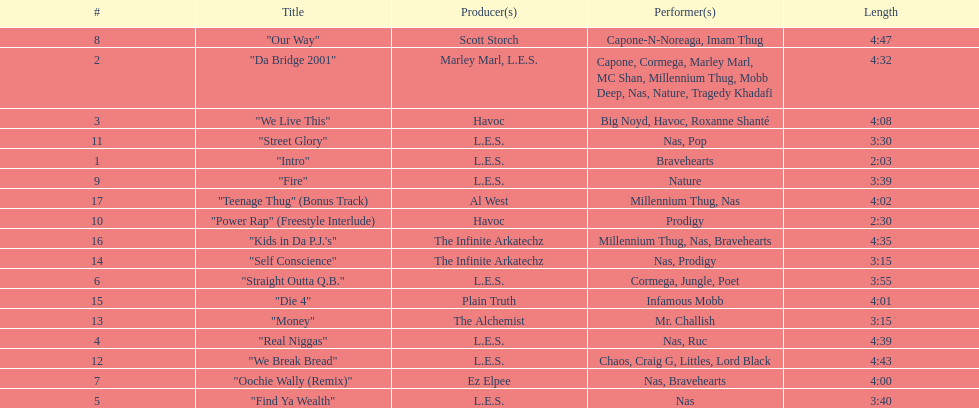What song was performed before "fire"? "Our Way". 